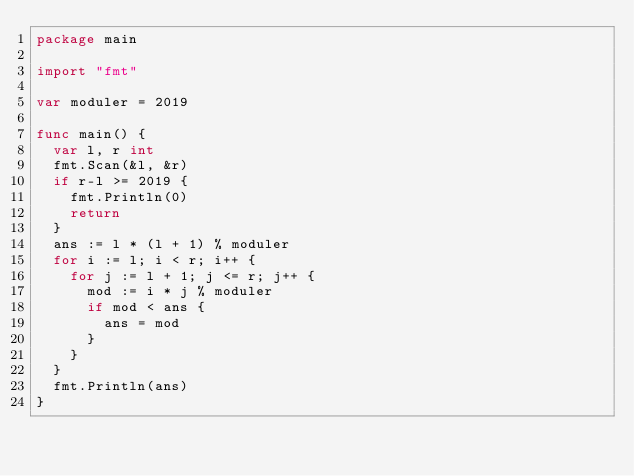<code> <loc_0><loc_0><loc_500><loc_500><_Go_>package main

import "fmt"

var moduler = 2019

func main() {
	var l, r int
	fmt.Scan(&l, &r)
	if r-l >= 2019 {
		fmt.Println(0)
		return
	}
	ans := l * (l + 1) % moduler
	for i := l; i < r; i++ {
		for j := l + 1; j <= r; j++ {
			mod := i * j % moduler
			if mod < ans {
				ans = mod
			}
		}
	}
	fmt.Println(ans)
}
</code> 